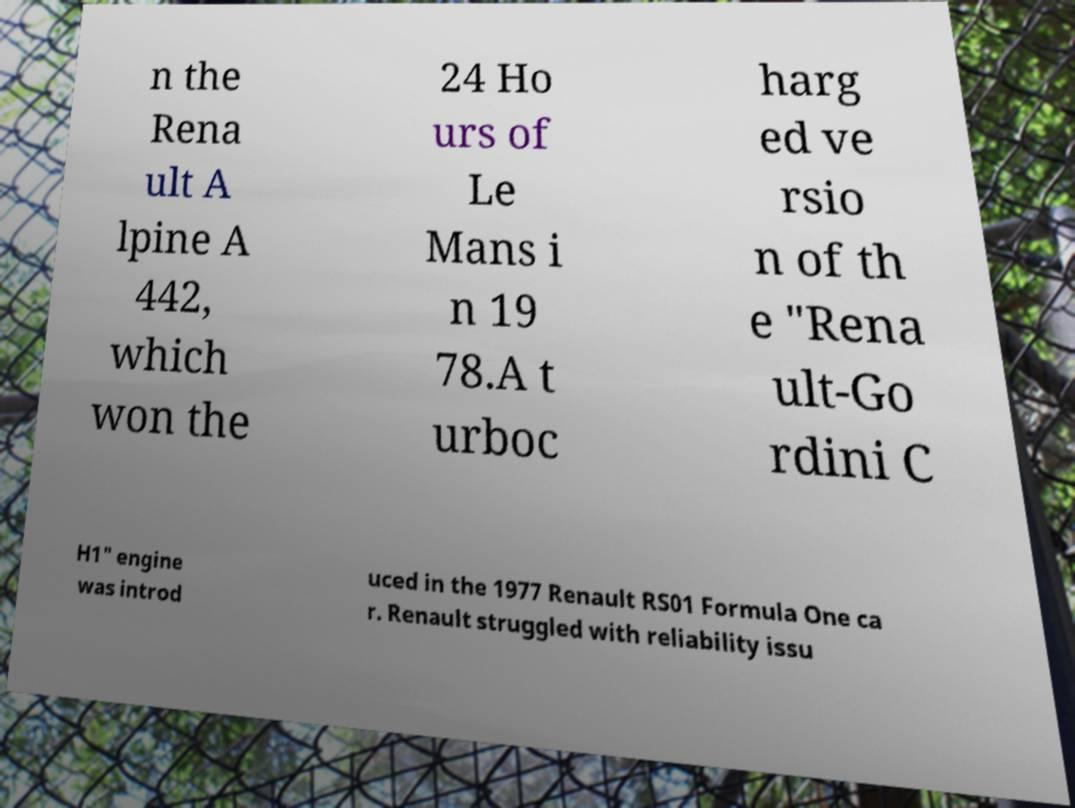Please read and relay the text visible in this image. What does it say? n the Rena ult A lpine A 442, which won the 24 Ho urs of Le Mans i n 19 78.A t urboc harg ed ve rsio n of th e "Rena ult-Go rdini C H1" engine was introd uced in the 1977 Renault RS01 Formula One ca r. Renault struggled with reliability issu 